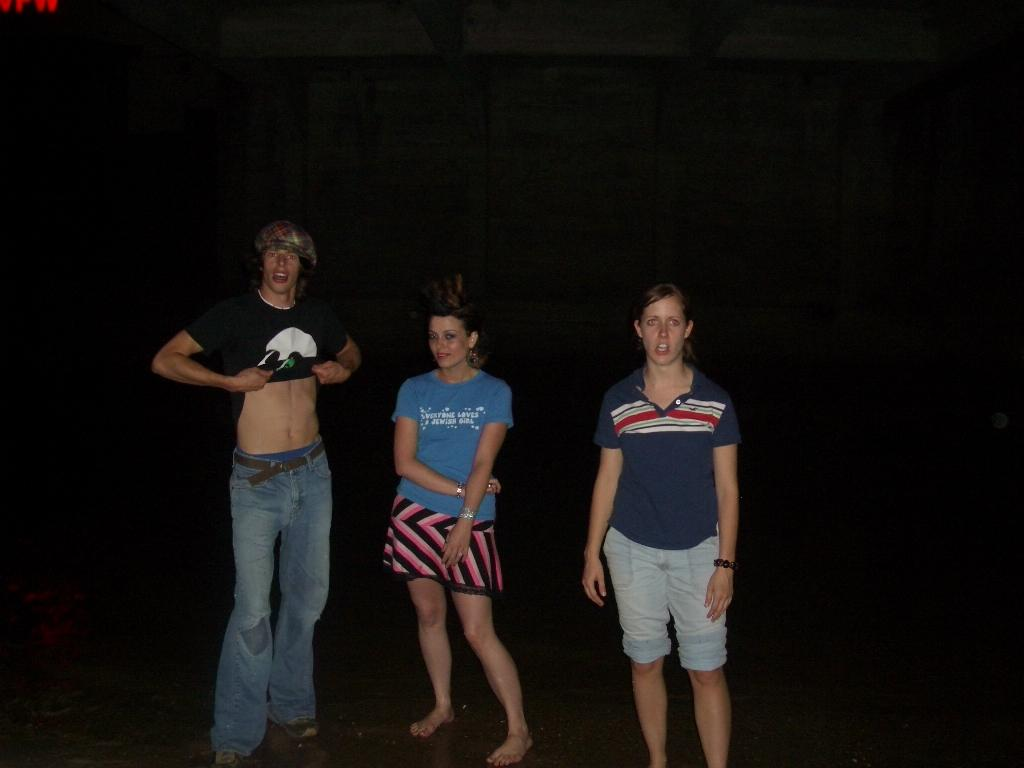<image>
Present a compact description of the photo's key features. Three people are on a beach and one of their shirts says Everyone Loves A Jewish Girl. 